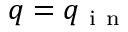Convert formula to latex. <formula><loc_0><loc_0><loc_500><loc_500>q = q _ { i n }</formula> 